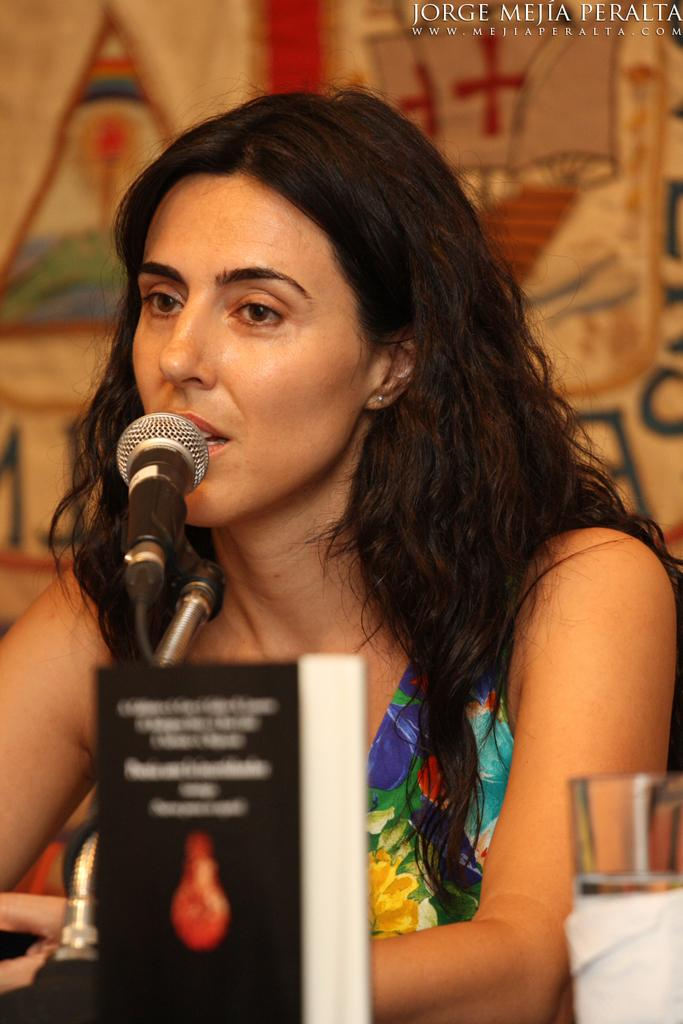What is the main subject of the image? There is a person in the image. What is the person doing in the image? The person is in front of a mic. What object can be seen in the bottom right of the image? There is a glass in the bottom right of the image. Can you describe the background of the image? The background of the image is blurred. How many deer can be seen in the image? There are no deer present in the image. What effect does the person's voice have on the ducks in the image? There are no ducks present in the image, so it is not possible to determine any effect on them. 